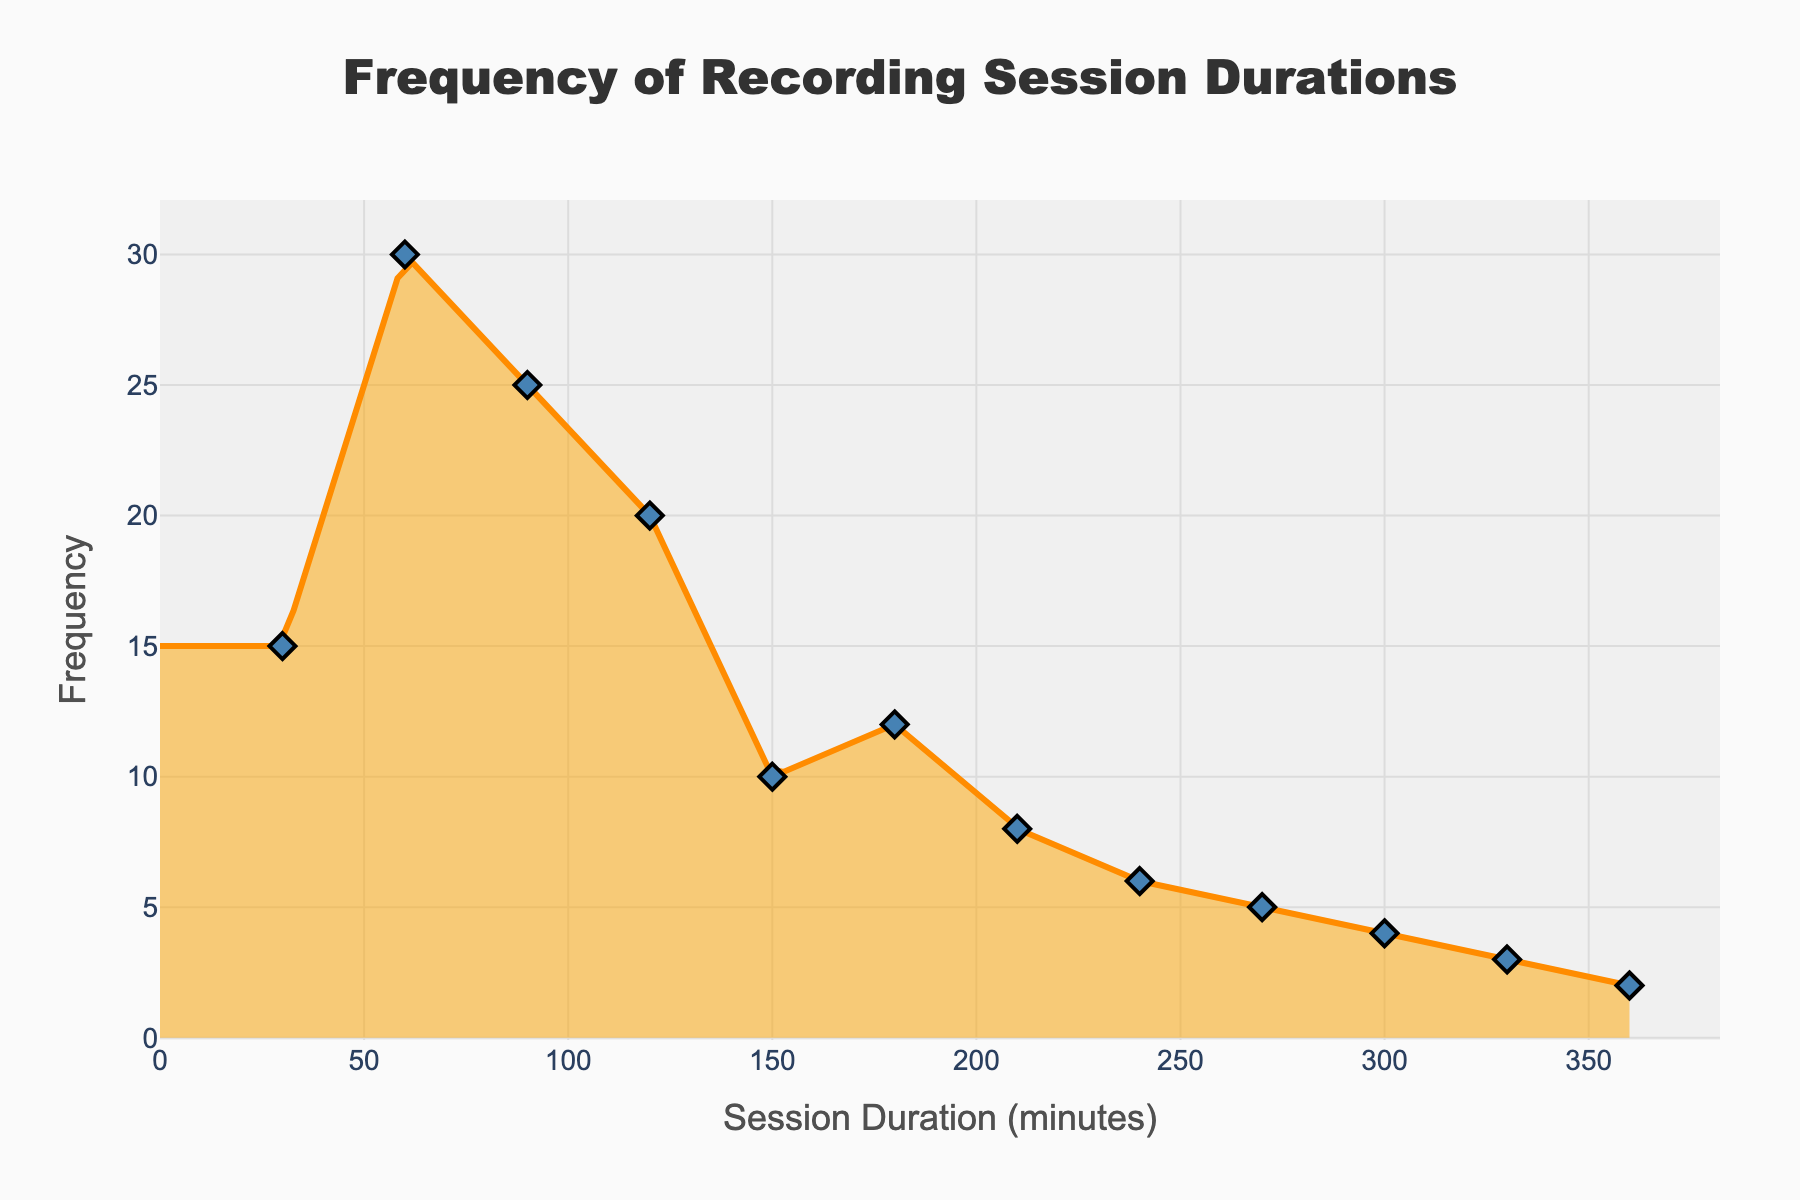What's the title of the figure? The title is usually located at the top of the figure, typically in a larger and bold font.
Answer: Frequency of Recording Session Durations What is the axis title for the horizontal axis? The horizontal axis title can be found at the bottom of the figure along the x-axis.
Answer: Session Duration (minutes) What is the axis title for the vertical axis? The vertical axis title can be found on the left side of the figure along the y-axis.
Answer: Frequency How many data points are depicted in the figure? The number of data points can be counted by the markers represented along the line.
Answer: 12 Which recording session duration has the highest frequency? The highest point on the density curve represents the highest frequency.
Answer: 60 minutes What is the frequency value for the recording session duration of 90 minutes? The y-value corresponding to the x-axis value of 90 minutes represents the frequency.
Answer: 25 How does the frequency of 120-minute sessions compare to that of 30-minute sessions? Look at the frequency values on the y-axis for the given x-axis values and compare them.
Answer: 120-minute sessions have a higher frequency than 30-minute sessions What is the total frequency of recording sessions lasting between 30 and 90 minutes? Add the frequency values for the session durations of 30, 60, and 90 minutes.
Answer: 15 (30 minutes) + 30 (60 minutes) + 25 (90 minutes) = 70 Are there more recording sessions that last less than 180 minutes or those that last more? Sum the frequencies for durations less than 180 minutes and those for durations greater than or equal to 180 minutes, and compare.
Answer: There are more recording sessions that last less than 180 minutes What's the average frequency of recording sessions longer than 240 minutes? Sum the frequencies for durations of 270, 300, 330, and 360 minutes, then divide by the number of these data points.
Answer: (5 + 4 + 3 + 2) / 4 = 3.5 